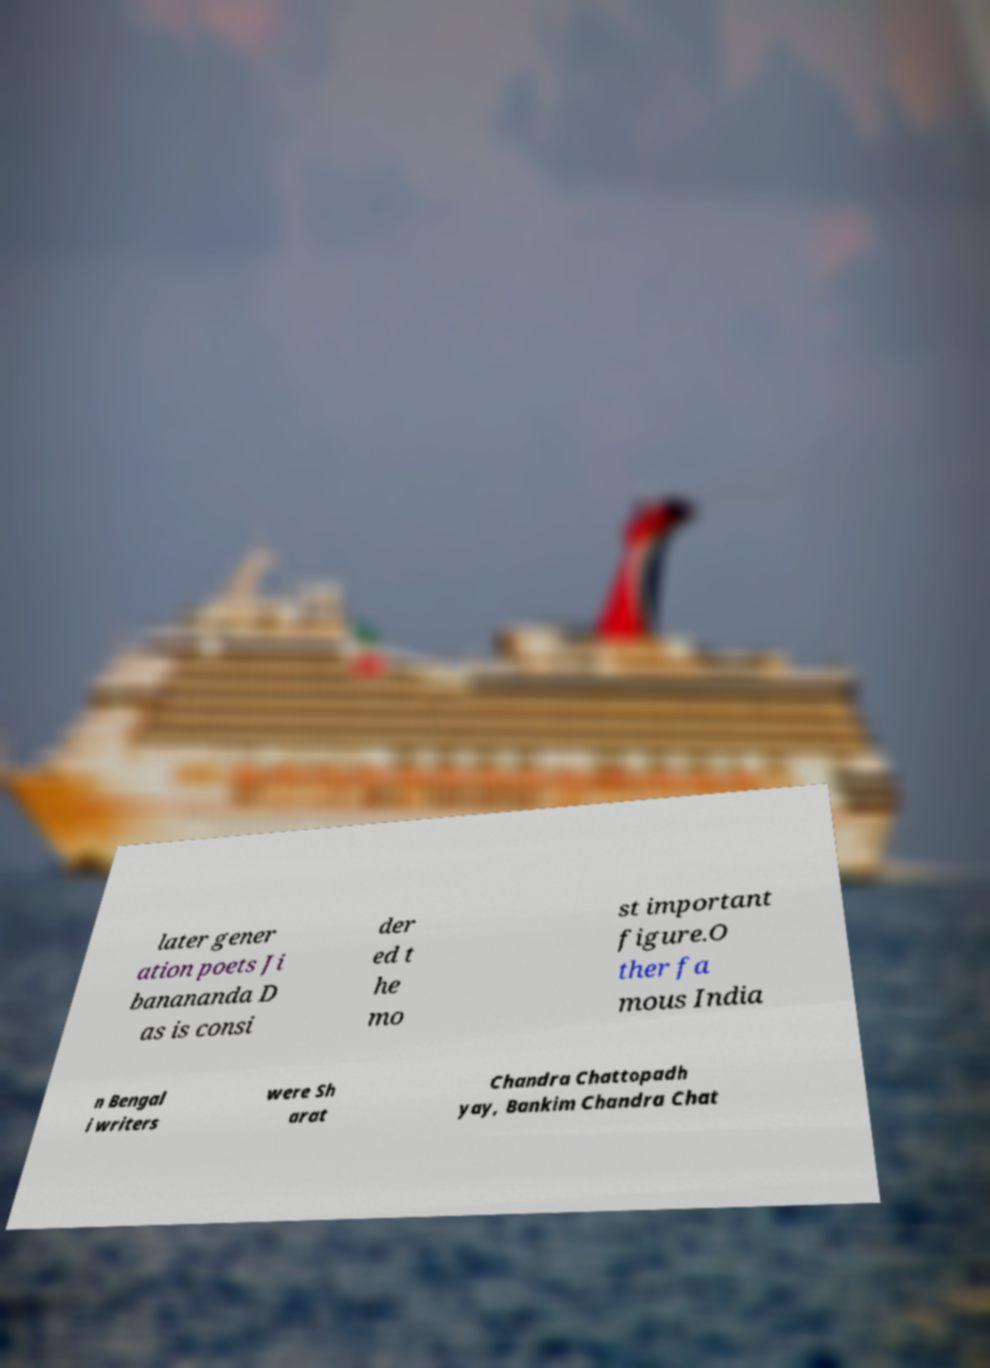Please identify and transcribe the text found in this image. later gener ation poets Ji banananda D as is consi der ed t he mo st important figure.O ther fa mous India n Bengal i writers were Sh arat Chandra Chattopadh yay, Bankim Chandra Chat 